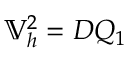Convert formula to latex. <formula><loc_0><loc_0><loc_500><loc_500>\mathbb { V } _ { h } ^ { 2 } = D Q _ { 1 }</formula> 